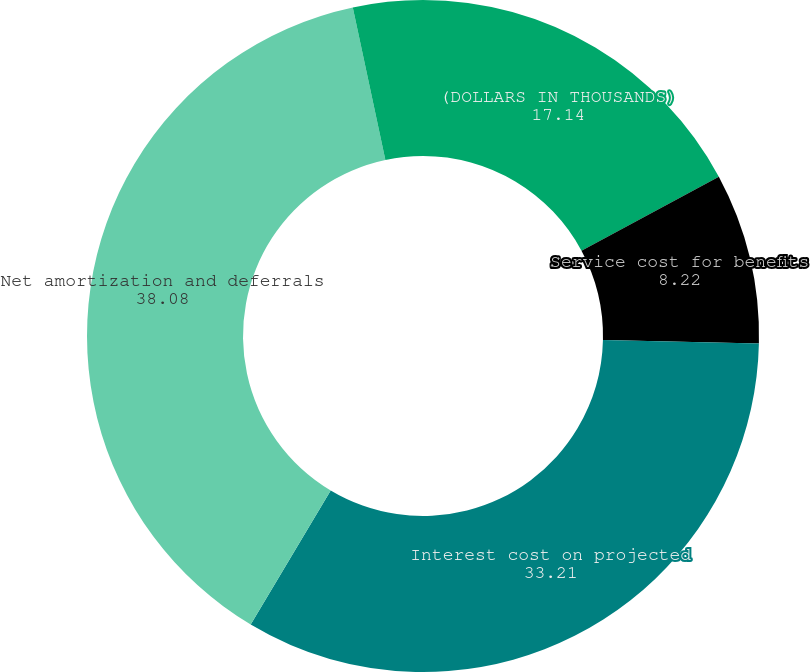Convert chart to OTSL. <chart><loc_0><loc_0><loc_500><loc_500><pie_chart><fcel>(DOLLARS IN THOUSANDS)<fcel>Service cost for benefits<fcel>Interest cost on projected<fcel>Net amortization and deferrals<fcel>(Credit) Expense<nl><fcel>17.14%<fcel>8.22%<fcel>33.21%<fcel>38.08%<fcel>3.35%<nl></chart> 